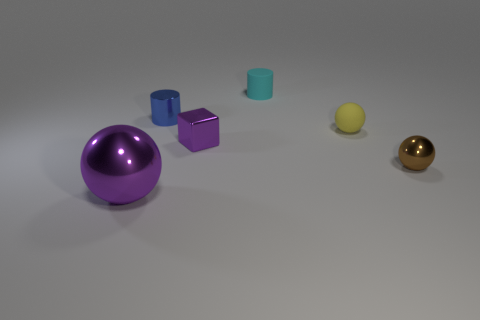How many objects are purple metallic objects in front of the brown metal thing or tiny cylinders?
Your answer should be very brief. 3. There is a small cube that is the same color as the large object; what material is it?
Your response must be concise. Metal. There is a metallic ball that is on the left side of the yellow thing that is on the right side of the big shiny sphere; are there any tiny purple blocks that are left of it?
Offer a very short reply. No. Are there fewer small blue metallic cylinders right of the tiny metal cube than tiny matte things right of the brown metallic sphere?
Offer a very short reply. No. The other sphere that is the same material as the tiny brown ball is what color?
Give a very brief answer. Purple. There is a thing that is to the left of the blue metallic cylinder behind the tiny metal block; what color is it?
Offer a very short reply. Purple. Is there a tiny metallic cube of the same color as the rubber sphere?
Offer a terse response. No. There is a yellow thing that is the same size as the metal block; what is its shape?
Ensure brevity in your answer.  Sphere. There is a metallic sphere that is on the left side of the small purple metal object; what number of tiny brown shiny balls are to the right of it?
Keep it short and to the point. 1. Does the metallic block have the same color as the small metallic ball?
Your answer should be compact. No. 